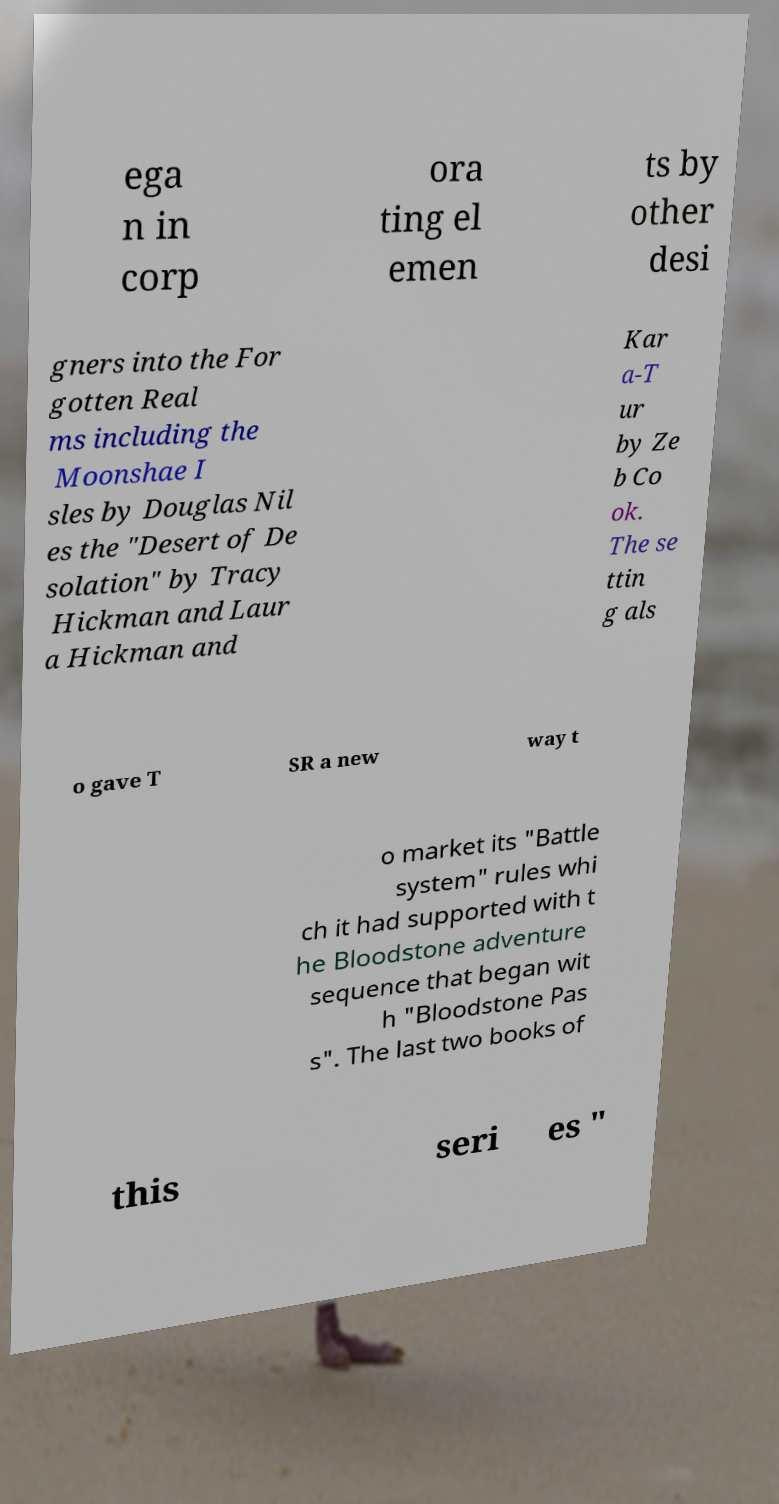I need the written content from this picture converted into text. Can you do that? ega n in corp ora ting el emen ts by other desi gners into the For gotten Real ms including the Moonshae I sles by Douglas Nil es the "Desert of De solation" by Tracy Hickman and Laur a Hickman and Kar a-T ur by Ze b Co ok. The se ttin g als o gave T SR a new way t o market its "Battle system" rules whi ch it had supported with t he Bloodstone adventure sequence that began wit h "Bloodstone Pas s". The last two books of this seri es " 